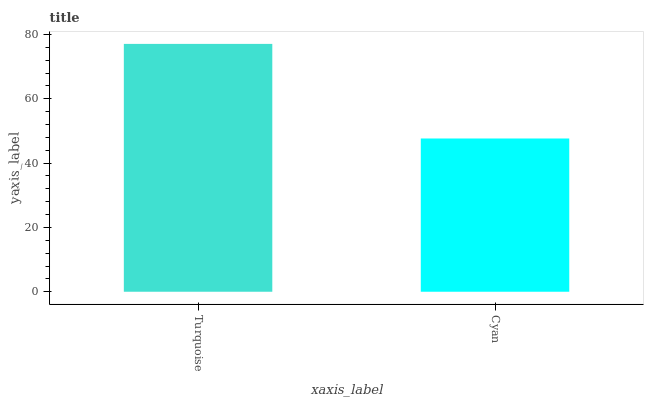Is Cyan the minimum?
Answer yes or no. Yes. Is Turquoise the maximum?
Answer yes or no. Yes. Is Cyan the maximum?
Answer yes or no. No. Is Turquoise greater than Cyan?
Answer yes or no. Yes. Is Cyan less than Turquoise?
Answer yes or no. Yes. Is Cyan greater than Turquoise?
Answer yes or no. No. Is Turquoise less than Cyan?
Answer yes or no. No. Is Turquoise the high median?
Answer yes or no. Yes. Is Cyan the low median?
Answer yes or no. Yes. Is Cyan the high median?
Answer yes or no. No. Is Turquoise the low median?
Answer yes or no. No. 